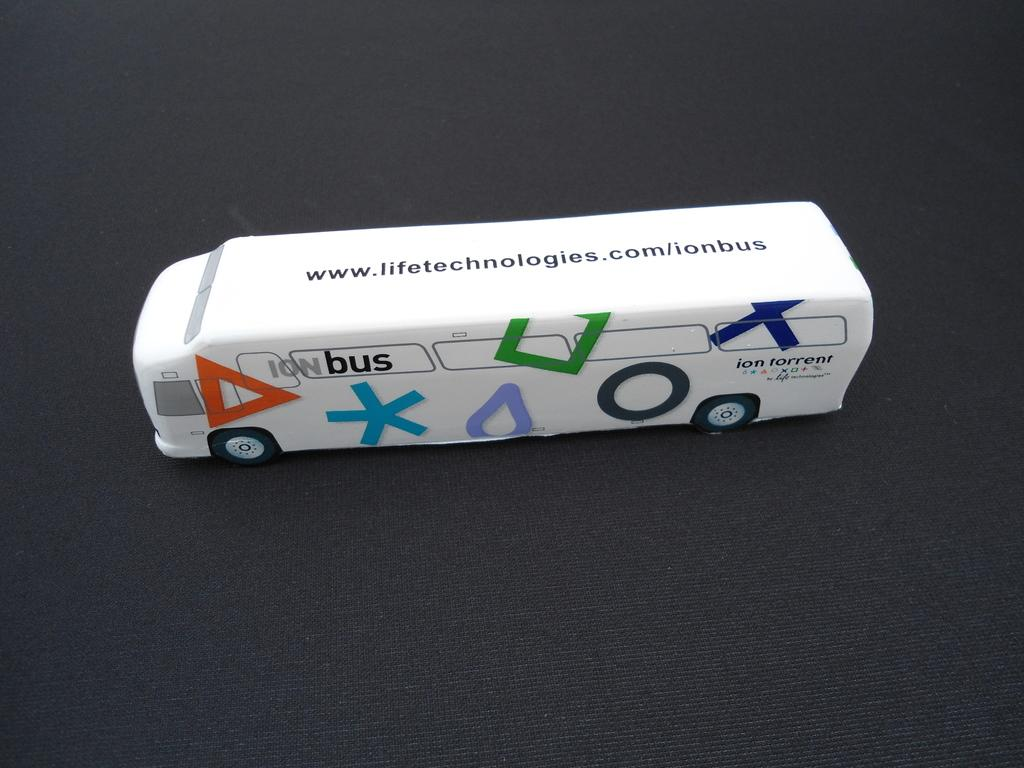What type of toy is present in the image? There is a white toy in the image that resembles a bus. What is the toy placed on in the image? The toy is on a black sheet in the image. What type of song is being sung by the horses in the image? There are no horses or songs present in the image; it features a white toy bus on a black sheet. 